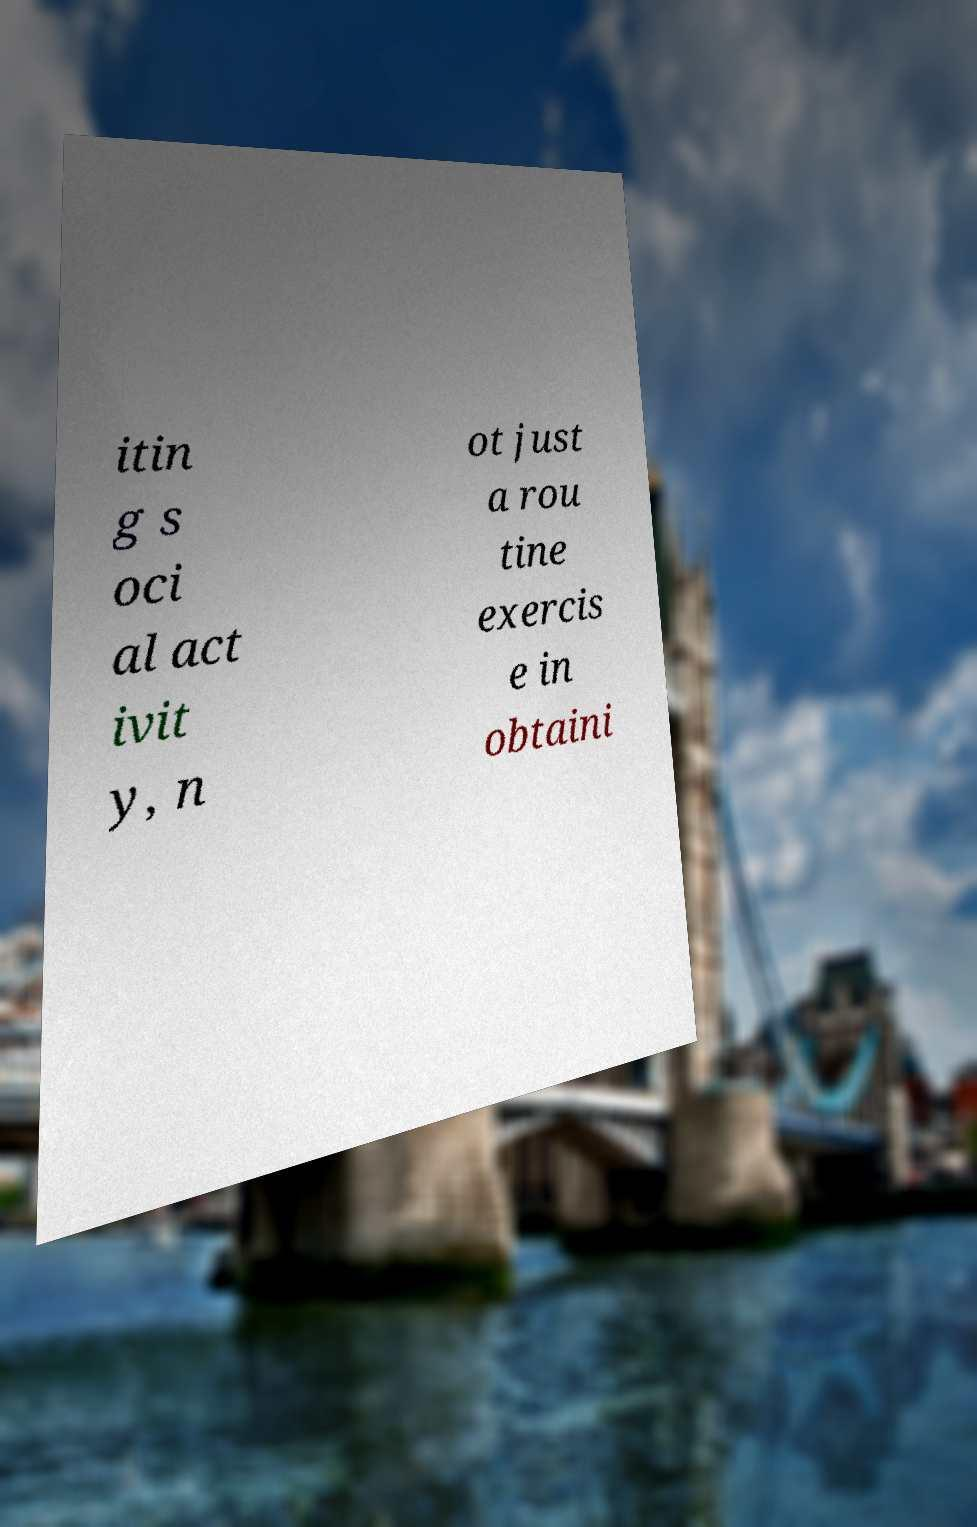What messages or text are displayed in this image? I need them in a readable, typed format. itin g s oci al act ivit y, n ot just a rou tine exercis e in obtaini 